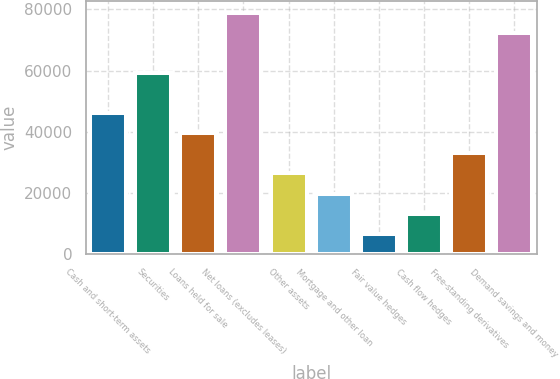Convert chart to OTSL. <chart><loc_0><loc_0><loc_500><loc_500><bar_chart><fcel>Cash and short-term assets<fcel>Securities<fcel>Loans held for sale<fcel>Net loans (excludes leases)<fcel>Other assets<fcel>Mortgage and other loan<fcel>Fair value hedges<fcel>Cash flow hedges<fcel>Free-standing derivatives<fcel>Demand savings and money<nl><fcel>46104.3<fcel>59240.1<fcel>39536.4<fcel>78943.8<fcel>26400.6<fcel>19832.7<fcel>6696.9<fcel>13264.8<fcel>32968.5<fcel>72375.9<nl></chart> 